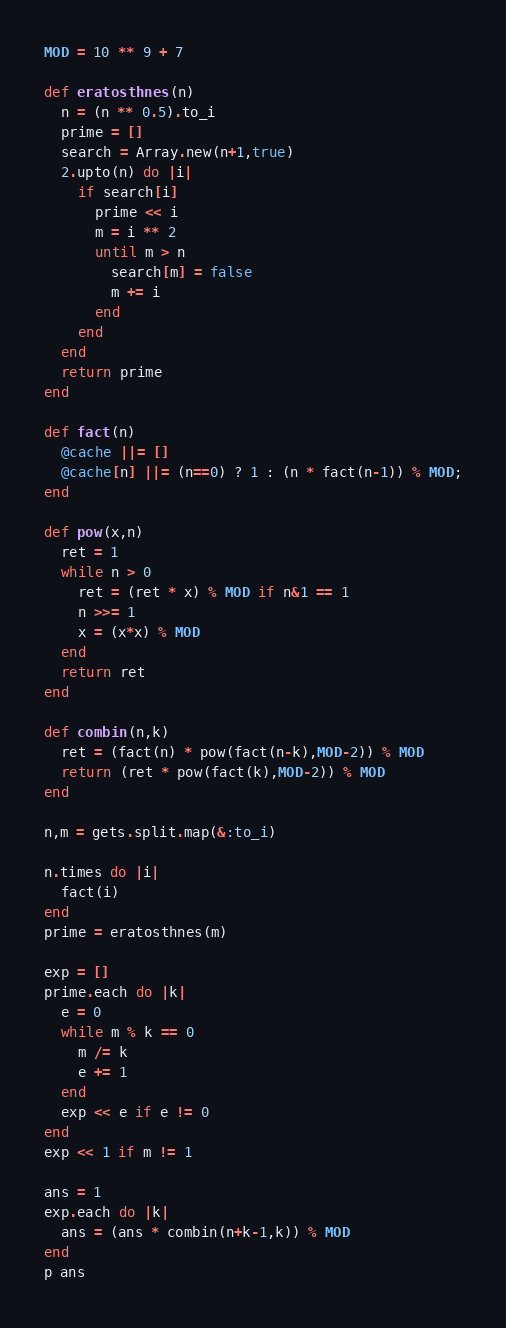<code> <loc_0><loc_0><loc_500><loc_500><_Ruby_>MOD = 10 ** 9 + 7

def eratosthnes(n)
  n = (n ** 0.5).to_i
  prime = []
  search = Array.new(n+1,true)
  2.upto(n) do |i|
    if search[i]
      prime << i
      m = i ** 2
      until m > n
        search[m] = false
        m += i
      end
    end
  end
  return prime
end

def fact(n)
  @cache ||= []
  @cache[n] ||= (n==0) ? 1 : (n * fact(n-1)) % MOD;
end

def pow(x,n)
  ret = 1
  while n > 0
    ret = (ret * x) % MOD if n&1 == 1
    n >>= 1
    x = (x*x) % MOD
  end
  return ret
end

def combin(n,k)
  ret = (fact(n) * pow(fact(n-k),MOD-2)) % MOD
  return (ret * pow(fact(k),MOD-2)) % MOD
end

n,m = gets.split.map(&:to_i)

n.times do |i|
  fact(i)
end
prime = eratosthnes(m)

exp = []
prime.each do |k|
  e = 0
  while m % k == 0
    m /= k
    e += 1
  end
  exp << e if e != 0
end
exp << 1 if m != 1

ans = 1
exp.each do |k|
  ans = (ans * combin(n+k-1,k)) % MOD
end
p ans</code> 